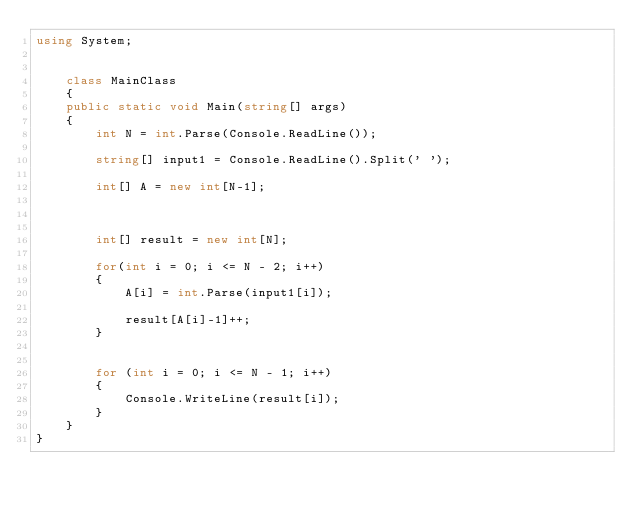<code> <loc_0><loc_0><loc_500><loc_500><_C#_>using System;


    class MainClass
    {
    public static void Main(string[] args)
    {
        int N = int.Parse(Console.ReadLine());

        string[] input1 = Console.ReadLine().Split(' ');

        int[] A = new int[N-1];

      

        int[] result = new int[N];

        for(int i = 0; i <= N - 2; i++)
        {
            A[i] = int.Parse(input1[i]);

            result[A[i]-1]++;
        }


        for (int i = 0; i <= N - 1; i++)
        {
            Console.WriteLine(result[i]);
        }
    }
}</code> 